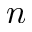Convert formula to latex. <formula><loc_0><loc_0><loc_500><loc_500>n</formula> 